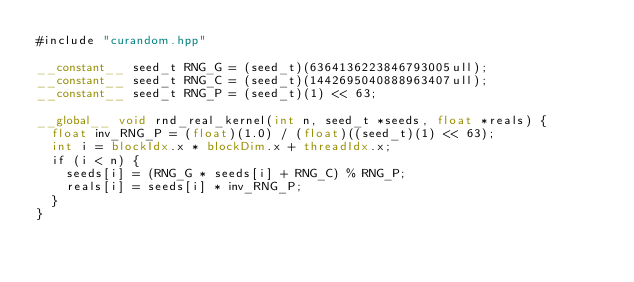<code> <loc_0><loc_0><loc_500><loc_500><_Cuda_>#include "curandom.hpp"

__constant__ seed_t RNG_G = (seed_t)(6364136223846793005ull);
__constant__ seed_t RNG_C = (seed_t)(1442695040888963407ull);
__constant__ seed_t RNG_P = (seed_t)(1) << 63;

__global__ void rnd_real_kernel(int n, seed_t *seeds, float *reals) {
  float inv_RNG_P = (float)(1.0) / (float)((seed_t)(1) << 63);
  int i = blockIdx.x * blockDim.x + threadIdx.x;
  if (i < n) {
    seeds[i] = (RNG_G * seeds[i] + RNG_C) % RNG_P;
    reals[i] = seeds[i] * inv_RNG_P;
  }
}
</code> 